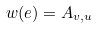Convert formula to latex. <formula><loc_0><loc_0><loc_500><loc_500>w ( e ) = A _ { v , u }</formula> 